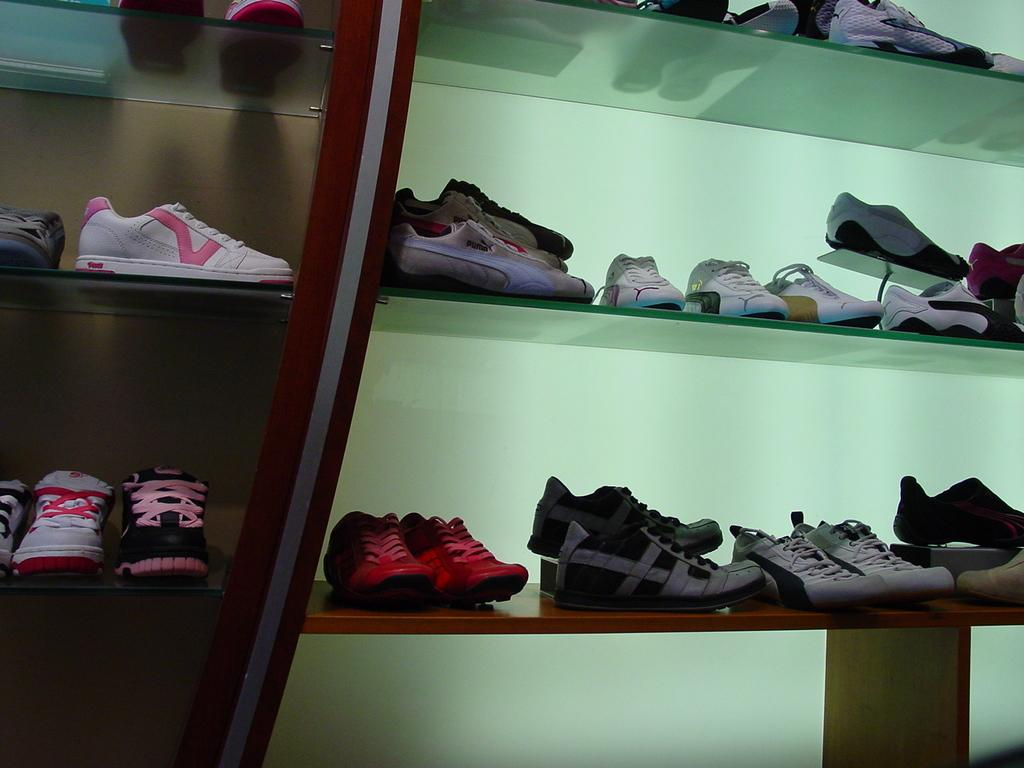What type of footwear is featured in the image? There are colorful shoes in the image. How are the shoes arranged in the image? The shoes are in a rack. What colors can be seen in the background of the image? The background of the image is green and brown. What type of trouble can be seen in the image? There is no trouble depicted in the image; it features colorful shoes in a rack with a green and brown background. 